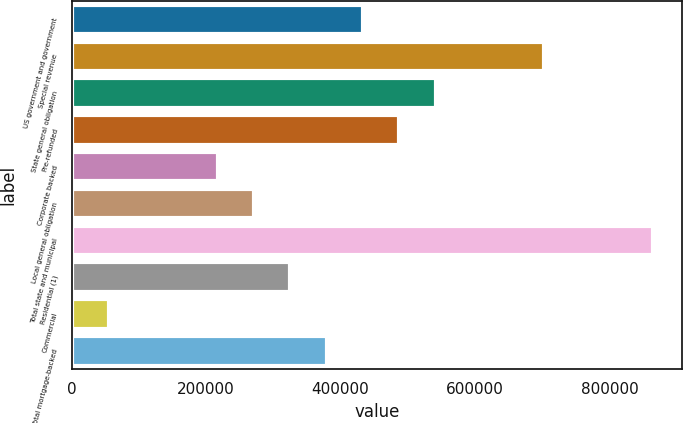<chart> <loc_0><loc_0><loc_500><loc_500><bar_chart><fcel>US government and government<fcel>Special revenue<fcel>State general obligation<fcel>Pre-refunded<fcel>Corporate backed<fcel>Local general obligation<fcel>Total state and municipal<fcel>Residential (1)<fcel>Commercial<fcel>Total mortgage-backed<nl><fcel>433410<fcel>703435<fcel>541420<fcel>487415<fcel>217390<fcel>271395<fcel>865450<fcel>325400<fcel>55375<fcel>379405<nl></chart> 